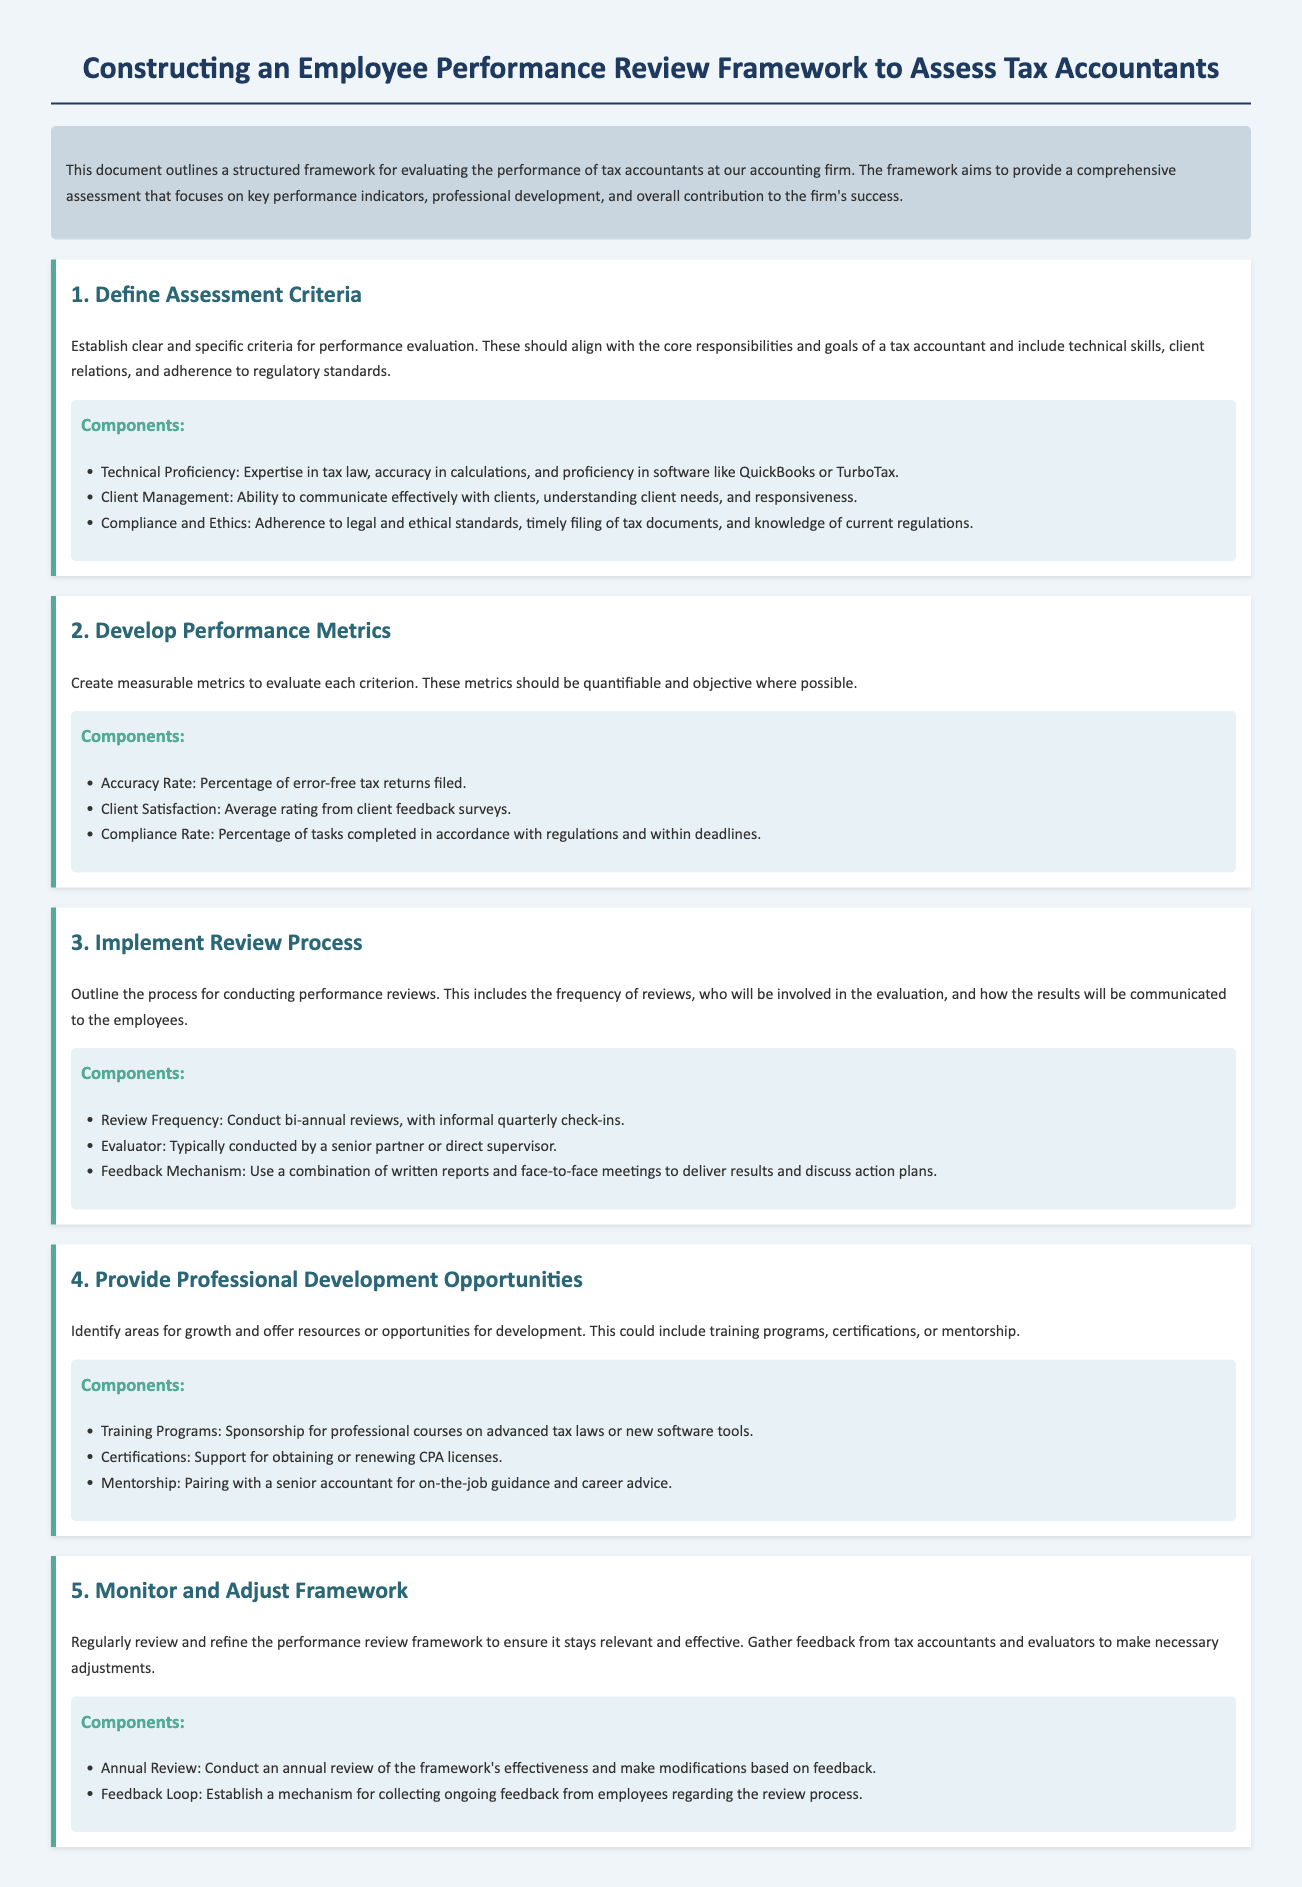What is the purpose of the document? The document outlines a structured framework for evaluating the performance of tax accountants at the accounting firm.
Answer: Performance evaluation framework What are the three components of technical proficiency? The components are listed in the framework under the criteria for performance evaluation.
Answer: Expertise in tax law, accuracy in calculations, proficiency in software How often are performance reviews conducted? The document specifies the frequency of reviews to be conducted.
Answer: Bi-annual Who typically conducts the performance evaluations? The evaluator role is defined in the review process section.
Answer: Senior partner or direct supervisor What is the focus of the professional development opportunities? The opportunities are aimed at enhancing growth and resources for development in tax accountants.
Answer: Areas for growth What percentage of error-free tax returns filed is considered an accuracy rate? The accuracy rate is described as a measurable metric in the framework.
Answer: Percentage of error-free tax returns What should be established for ongoing feedback? The document outlines a mechanism for continuously collecting feedback on the review process.
Answer: Feedback loop What is the final step in the performance review framework? The last step is about reviewing and refining the framework for relevance and effectiveness.
Answer: Monitor and Adjust Framework 